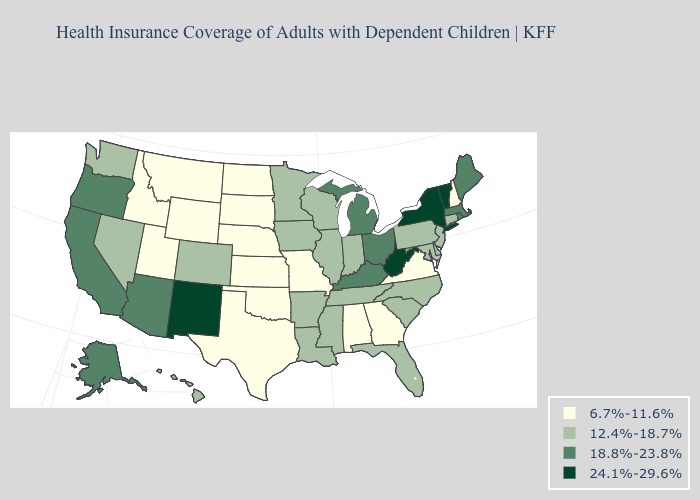What is the value of Massachusetts?
Answer briefly. 18.8%-23.8%. What is the highest value in states that border Texas?
Give a very brief answer. 24.1%-29.6%. Name the states that have a value in the range 18.8%-23.8%?
Short answer required. Alaska, Arizona, California, Kentucky, Maine, Massachusetts, Michigan, Ohio, Oregon, Rhode Island. What is the value of South Dakota?
Answer briefly. 6.7%-11.6%. Does Kentucky have the highest value in the South?
Give a very brief answer. No. What is the highest value in the USA?
Concise answer only. 24.1%-29.6%. Does Delaware have the lowest value in the USA?
Quick response, please. No. Among the states that border New Jersey , does New York have the highest value?
Short answer required. Yes. Name the states that have a value in the range 18.8%-23.8%?
Keep it brief. Alaska, Arizona, California, Kentucky, Maine, Massachusetts, Michigan, Ohio, Oregon, Rhode Island. What is the value of Arizona?
Keep it brief. 18.8%-23.8%. Which states have the lowest value in the Northeast?
Concise answer only. New Hampshire. Does South Dakota have the highest value in the MidWest?
Concise answer only. No. What is the value of Montana?
Give a very brief answer. 6.7%-11.6%. Name the states that have a value in the range 6.7%-11.6%?
Answer briefly. Alabama, Georgia, Idaho, Kansas, Missouri, Montana, Nebraska, New Hampshire, North Dakota, Oklahoma, South Dakota, Texas, Utah, Virginia, Wyoming. What is the value of Texas?
Give a very brief answer. 6.7%-11.6%. 